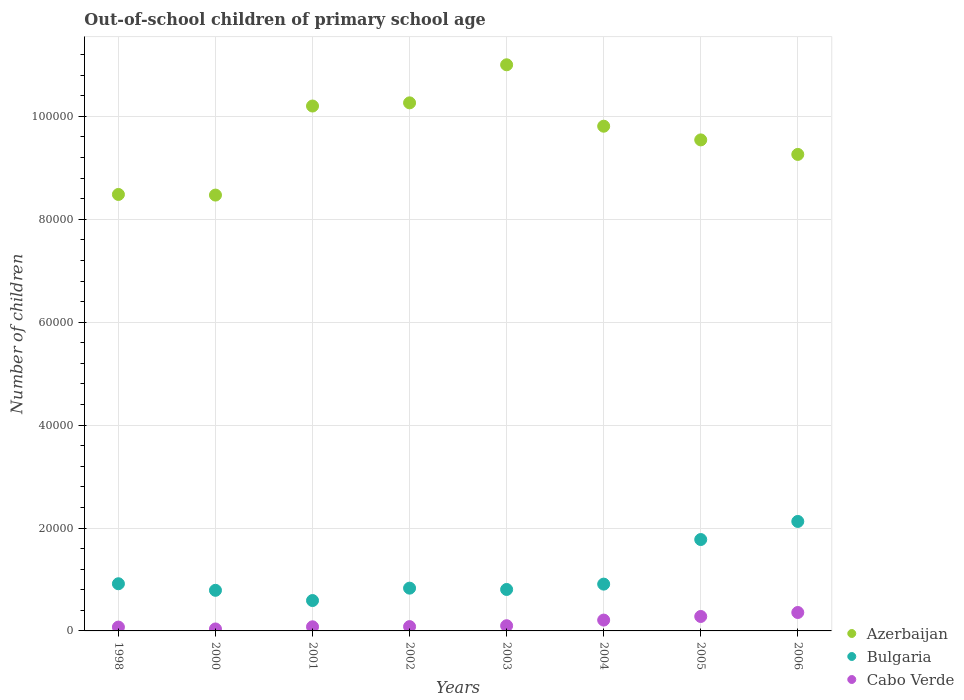What is the number of out-of-school children in Bulgaria in 2000?
Provide a short and direct response. 7892. Across all years, what is the maximum number of out-of-school children in Azerbaijan?
Your answer should be very brief. 1.10e+05. Across all years, what is the minimum number of out-of-school children in Cabo Verde?
Provide a succinct answer. 381. In which year was the number of out-of-school children in Bulgaria maximum?
Make the answer very short. 2006. In which year was the number of out-of-school children in Cabo Verde minimum?
Offer a terse response. 2000. What is the total number of out-of-school children in Azerbaijan in the graph?
Offer a very short reply. 7.70e+05. What is the difference between the number of out-of-school children in Cabo Verde in 2000 and that in 2006?
Offer a terse response. -3200. What is the difference between the number of out-of-school children in Azerbaijan in 2004 and the number of out-of-school children in Cabo Verde in 2005?
Offer a terse response. 9.53e+04. What is the average number of out-of-school children in Bulgaria per year?
Offer a terse response. 1.09e+04. In the year 1998, what is the difference between the number of out-of-school children in Azerbaijan and number of out-of-school children in Cabo Verde?
Keep it short and to the point. 8.41e+04. In how many years, is the number of out-of-school children in Bulgaria greater than 32000?
Make the answer very short. 0. What is the ratio of the number of out-of-school children in Azerbaijan in 2000 to that in 2002?
Give a very brief answer. 0.83. Is the number of out-of-school children in Cabo Verde in 2002 less than that in 2005?
Your answer should be very brief. Yes. Is the difference between the number of out-of-school children in Azerbaijan in 2001 and 2002 greater than the difference between the number of out-of-school children in Cabo Verde in 2001 and 2002?
Offer a very short reply. No. What is the difference between the highest and the second highest number of out-of-school children in Cabo Verde?
Offer a very short reply. 774. What is the difference between the highest and the lowest number of out-of-school children in Azerbaijan?
Your answer should be compact. 2.53e+04. Is the sum of the number of out-of-school children in Cabo Verde in 2003 and 2005 greater than the maximum number of out-of-school children in Bulgaria across all years?
Provide a short and direct response. No. Is the number of out-of-school children in Azerbaijan strictly greater than the number of out-of-school children in Bulgaria over the years?
Your answer should be very brief. Yes. How many dotlines are there?
Keep it short and to the point. 3. How many years are there in the graph?
Your answer should be very brief. 8. Does the graph contain grids?
Provide a succinct answer. Yes. How many legend labels are there?
Your answer should be compact. 3. What is the title of the graph?
Ensure brevity in your answer.  Out-of-school children of primary school age. What is the label or title of the X-axis?
Offer a very short reply. Years. What is the label or title of the Y-axis?
Ensure brevity in your answer.  Number of children. What is the Number of children in Azerbaijan in 1998?
Your response must be concise. 8.48e+04. What is the Number of children of Bulgaria in 1998?
Make the answer very short. 9167. What is the Number of children of Cabo Verde in 1998?
Offer a terse response. 745. What is the Number of children of Azerbaijan in 2000?
Offer a very short reply. 8.47e+04. What is the Number of children in Bulgaria in 2000?
Offer a very short reply. 7892. What is the Number of children of Cabo Verde in 2000?
Provide a short and direct response. 381. What is the Number of children of Azerbaijan in 2001?
Your answer should be compact. 1.02e+05. What is the Number of children in Bulgaria in 2001?
Your answer should be very brief. 5904. What is the Number of children in Cabo Verde in 2001?
Make the answer very short. 801. What is the Number of children of Azerbaijan in 2002?
Make the answer very short. 1.03e+05. What is the Number of children in Bulgaria in 2002?
Your answer should be very brief. 8312. What is the Number of children of Cabo Verde in 2002?
Provide a succinct answer. 836. What is the Number of children of Azerbaijan in 2003?
Give a very brief answer. 1.10e+05. What is the Number of children of Bulgaria in 2003?
Provide a short and direct response. 8057. What is the Number of children in Cabo Verde in 2003?
Offer a terse response. 1011. What is the Number of children in Azerbaijan in 2004?
Make the answer very short. 9.81e+04. What is the Number of children of Bulgaria in 2004?
Your response must be concise. 9096. What is the Number of children of Cabo Verde in 2004?
Your answer should be very brief. 2106. What is the Number of children in Azerbaijan in 2005?
Ensure brevity in your answer.  9.54e+04. What is the Number of children in Bulgaria in 2005?
Give a very brief answer. 1.78e+04. What is the Number of children in Cabo Verde in 2005?
Your answer should be compact. 2807. What is the Number of children in Azerbaijan in 2006?
Make the answer very short. 9.26e+04. What is the Number of children of Bulgaria in 2006?
Offer a very short reply. 2.13e+04. What is the Number of children in Cabo Verde in 2006?
Provide a short and direct response. 3581. Across all years, what is the maximum Number of children in Azerbaijan?
Offer a terse response. 1.10e+05. Across all years, what is the maximum Number of children of Bulgaria?
Your answer should be compact. 2.13e+04. Across all years, what is the maximum Number of children of Cabo Verde?
Provide a succinct answer. 3581. Across all years, what is the minimum Number of children of Azerbaijan?
Provide a short and direct response. 8.47e+04. Across all years, what is the minimum Number of children of Bulgaria?
Provide a succinct answer. 5904. Across all years, what is the minimum Number of children of Cabo Verde?
Your response must be concise. 381. What is the total Number of children of Azerbaijan in the graph?
Offer a very short reply. 7.70e+05. What is the total Number of children of Bulgaria in the graph?
Provide a succinct answer. 8.75e+04. What is the total Number of children in Cabo Verde in the graph?
Your response must be concise. 1.23e+04. What is the difference between the Number of children of Azerbaijan in 1998 and that in 2000?
Ensure brevity in your answer.  121. What is the difference between the Number of children of Bulgaria in 1998 and that in 2000?
Offer a terse response. 1275. What is the difference between the Number of children of Cabo Verde in 1998 and that in 2000?
Keep it short and to the point. 364. What is the difference between the Number of children of Azerbaijan in 1998 and that in 2001?
Provide a succinct answer. -1.72e+04. What is the difference between the Number of children of Bulgaria in 1998 and that in 2001?
Offer a very short reply. 3263. What is the difference between the Number of children in Cabo Verde in 1998 and that in 2001?
Ensure brevity in your answer.  -56. What is the difference between the Number of children of Azerbaijan in 1998 and that in 2002?
Offer a very short reply. -1.78e+04. What is the difference between the Number of children in Bulgaria in 1998 and that in 2002?
Give a very brief answer. 855. What is the difference between the Number of children in Cabo Verde in 1998 and that in 2002?
Ensure brevity in your answer.  -91. What is the difference between the Number of children in Azerbaijan in 1998 and that in 2003?
Provide a short and direct response. -2.52e+04. What is the difference between the Number of children in Bulgaria in 1998 and that in 2003?
Provide a succinct answer. 1110. What is the difference between the Number of children in Cabo Verde in 1998 and that in 2003?
Provide a short and direct response. -266. What is the difference between the Number of children in Azerbaijan in 1998 and that in 2004?
Provide a succinct answer. -1.33e+04. What is the difference between the Number of children in Cabo Verde in 1998 and that in 2004?
Provide a succinct answer. -1361. What is the difference between the Number of children of Azerbaijan in 1998 and that in 2005?
Your answer should be very brief. -1.06e+04. What is the difference between the Number of children in Bulgaria in 1998 and that in 2005?
Your answer should be very brief. -8594. What is the difference between the Number of children in Cabo Verde in 1998 and that in 2005?
Make the answer very short. -2062. What is the difference between the Number of children of Azerbaijan in 1998 and that in 2006?
Offer a terse response. -7781. What is the difference between the Number of children in Bulgaria in 1998 and that in 2006?
Give a very brief answer. -1.21e+04. What is the difference between the Number of children in Cabo Verde in 1998 and that in 2006?
Provide a short and direct response. -2836. What is the difference between the Number of children of Azerbaijan in 2000 and that in 2001?
Your response must be concise. -1.73e+04. What is the difference between the Number of children of Bulgaria in 2000 and that in 2001?
Offer a very short reply. 1988. What is the difference between the Number of children of Cabo Verde in 2000 and that in 2001?
Provide a succinct answer. -420. What is the difference between the Number of children in Azerbaijan in 2000 and that in 2002?
Your answer should be compact. -1.79e+04. What is the difference between the Number of children of Bulgaria in 2000 and that in 2002?
Offer a very short reply. -420. What is the difference between the Number of children in Cabo Verde in 2000 and that in 2002?
Provide a succinct answer. -455. What is the difference between the Number of children in Azerbaijan in 2000 and that in 2003?
Provide a succinct answer. -2.53e+04. What is the difference between the Number of children in Bulgaria in 2000 and that in 2003?
Offer a very short reply. -165. What is the difference between the Number of children of Cabo Verde in 2000 and that in 2003?
Offer a terse response. -630. What is the difference between the Number of children of Azerbaijan in 2000 and that in 2004?
Your answer should be compact. -1.34e+04. What is the difference between the Number of children of Bulgaria in 2000 and that in 2004?
Keep it short and to the point. -1204. What is the difference between the Number of children in Cabo Verde in 2000 and that in 2004?
Give a very brief answer. -1725. What is the difference between the Number of children of Azerbaijan in 2000 and that in 2005?
Your answer should be compact. -1.07e+04. What is the difference between the Number of children in Bulgaria in 2000 and that in 2005?
Offer a very short reply. -9869. What is the difference between the Number of children of Cabo Verde in 2000 and that in 2005?
Keep it short and to the point. -2426. What is the difference between the Number of children in Azerbaijan in 2000 and that in 2006?
Your response must be concise. -7902. What is the difference between the Number of children of Bulgaria in 2000 and that in 2006?
Offer a very short reply. -1.34e+04. What is the difference between the Number of children of Cabo Verde in 2000 and that in 2006?
Provide a succinct answer. -3200. What is the difference between the Number of children of Azerbaijan in 2001 and that in 2002?
Keep it short and to the point. -618. What is the difference between the Number of children in Bulgaria in 2001 and that in 2002?
Provide a succinct answer. -2408. What is the difference between the Number of children of Cabo Verde in 2001 and that in 2002?
Make the answer very short. -35. What is the difference between the Number of children of Azerbaijan in 2001 and that in 2003?
Your response must be concise. -8015. What is the difference between the Number of children in Bulgaria in 2001 and that in 2003?
Make the answer very short. -2153. What is the difference between the Number of children in Cabo Verde in 2001 and that in 2003?
Keep it short and to the point. -210. What is the difference between the Number of children in Azerbaijan in 2001 and that in 2004?
Offer a terse response. 3923. What is the difference between the Number of children in Bulgaria in 2001 and that in 2004?
Offer a very short reply. -3192. What is the difference between the Number of children of Cabo Verde in 2001 and that in 2004?
Make the answer very short. -1305. What is the difference between the Number of children in Azerbaijan in 2001 and that in 2005?
Give a very brief answer. 6583. What is the difference between the Number of children in Bulgaria in 2001 and that in 2005?
Give a very brief answer. -1.19e+04. What is the difference between the Number of children in Cabo Verde in 2001 and that in 2005?
Keep it short and to the point. -2006. What is the difference between the Number of children in Azerbaijan in 2001 and that in 2006?
Your answer should be compact. 9405. What is the difference between the Number of children of Bulgaria in 2001 and that in 2006?
Offer a terse response. -1.54e+04. What is the difference between the Number of children in Cabo Verde in 2001 and that in 2006?
Your response must be concise. -2780. What is the difference between the Number of children in Azerbaijan in 2002 and that in 2003?
Make the answer very short. -7397. What is the difference between the Number of children of Bulgaria in 2002 and that in 2003?
Your response must be concise. 255. What is the difference between the Number of children in Cabo Verde in 2002 and that in 2003?
Ensure brevity in your answer.  -175. What is the difference between the Number of children in Azerbaijan in 2002 and that in 2004?
Give a very brief answer. 4541. What is the difference between the Number of children in Bulgaria in 2002 and that in 2004?
Your response must be concise. -784. What is the difference between the Number of children of Cabo Verde in 2002 and that in 2004?
Your answer should be compact. -1270. What is the difference between the Number of children in Azerbaijan in 2002 and that in 2005?
Make the answer very short. 7201. What is the difference between the Number of children in Bulgaria in 2002 and that in 2005?
Give a very brief answer. -9449. What is the difference between the Number of children in Cabo Verde in 2002 and that in 2005?
Make the answer very short. -1971. What is the difference between the Number of children of Azerbaijan in 2002 and that in 2006?
Offer a very short reply. 1.00e+04. What is the difference between the Number of children of Bulgaria in 2002 and that in 2006?
Keep it short and to the point. -1.30e+04. What is the difference between the Number of children in Cabo Verde in 2002 and that in 2006?
Make the answer very short. -2745. What is the difference between the Number of children of Azerbaijan in 2003 and that in 2004?
Offer a very short reply. 1.19e+04. What is the difference between the Number of children of Bulgaria in 2003 and that in 2004?
Make the answer very short. -1039. What is the difference between the Number of children in Cabo Verde in 2003 and that in 2004?
Make the answer very short. -1095. What is the difference between the Number of children of Azerbaijan in 2003 and that in 2005?
Provide a succinct answer. 1.46e+04. What is the difference between the Number of children of Bulgaria in 2003 and that in 2005?
Provide a succinct answer. -9704. What is the difference between the Number of children of Cabo Verde in 2003 and that in 2005?
Provide a succinct answer. -1796. What is the difference between the Number of children in Azerbaijan in 2003 and that in 2006?
Offer a terse response. 1.74e+04. What is the difference between the Number of children in Bulgaria in 2003 and that in 2006?
Ensure brevity in your answer.  -1.32e+04. What is the difference between the Number of children in Cabo Verde in 2003 and that in 2006?
Provide a short and direct response. -2570. What is the difference between the Number of children in Azerbaijan in 2004 and that in 2005?
Offer a terse response. 2660. What is the difference between the Number of children of Bulgaria in 2004 and that in 2005?
Your answer should be compact. -8665. What is the difference between the Number of children in Cabo Verde in 2004 and that in 2005?
Your answer should be compact. -701. What is the difference between the Number of children of Azerbaijan in 2004 and that in 2006?
Give a very brief answer. 5482. What is the difference between the Number of children of Bulgaria in 2004 and that in 2006?
Provide a succinct answer. -1.22e+04. What is the difference between the Number of children of Cabo Verde in 2004 and that in 2006?
Provide a succinct answer. -1475. What is the difference between the Number of children of Azerbaijan in 2005 and that in 2006?
Provide a succinct answer. 2822. What is the difference between the Number of children of Bulgaria in 2005 and that in 2006?
Make the answer very short. -3516. What is the difference between the Number of children in Cabo Verde in 2005 and that in 2006?
Provide a succinct answer. -774. What is the difference between the Number of children of Azerbaijan in 1998 and the Number of children of Bulgaria in 2000?
Your answer should be compact. 7.69e+04. What is the difference between the Number of children of Azerbaijan in 1998 and the Number of children of Cabo Verde in 2000?
Offer a terse response. 8.44e+04. What is the difference between the Number of children in Bulgaria in 1998 and the Number of children in Cabo Verde in 2000?
Keep it short and to the point. 8786. What is the difference between the Number of children in Azerbaijan in 1998 and the Number of children in Bulgaria in 2001?
Your response must be concise. 7.89e+04. What is the difference between the Number of children of Azerbaijan in 1998 and the Number of children of Cabo Verde in 2001?
Provide a short and direct response. 8.40e+04. What is the difference between the Number of children of Bulgaria in 1998 and the Number of children of Cabo Verde in 2001?
Your answer should be very brief. 8366. What is the difference between the Number of children of Azerbaijan in 1998 and the Number of children of Bulgaria in 2002?
Provide a succinct answer. 7.65e+04. What is the difference between the Number of children in Azerbaijan in 1998 and the Number of children in Cabo Verde in 2002?
Give a very brief answer. 8.40e+04. What is the difference between the Number of children in Bulgaria in 1998 and the Number of children in Cabo Verde in 2002?
Provide a succinct answer. 8331. What is the difference between the Number of children of Azerbaijan in 1998 and the Number of children of Bulgaria in 2003?
Your answer should be compact. 7.68e+04. What is the difference between the Number of children of Azerbaijan in 1998 and the Number of children of Cabo Verde in 2003?
Ensure brevity in your answer.  8.38e+04. What is the difference between the Number of children in Bulgaria in 1998 and the Number of children in Cabo Verde in 2003?
Offer a terse response. 8156. What is the difference between the Number of children of Azerbaijan in 1998 and the Number of children of Bulgaria in 2004?
Your answer should be compact. 7.57e+04. What is the difference between the Number of children in Azerbaijan in 1998 and the Number of children in Cabo Verde in 2004?
Give a very brief answer. 8.27e+04. What is the difference between the Number of children of Bulgaria in 1998 and the Number of children of Cabo Verde in 2004?
Offer a very short reply. 7061. What is the difference between the Number of children in Azerbaijan in 1998 and the Number of children in Bulgaria in 2005?
Provide a short and direct response. 6.71e+04. What is the difference between the Number of children of Azerbaijan in 1998 and the Number of children of Cabo Verde in 2005?
Your answer should be compact. 8.20e+04. What is the difference between the Number of children in Bulgaria in 1998 and the Number of children in Cabo Verde in 2005?
Provide a succinct answer. 6360. What is the difference between the Number of children in Azerbaijan in 1998 and the Number of children in Bulgaria in 2006?
Provide a short and direct response. 6.35e+04. What is the difference between the Number of children of Azerbaijan in 1998 and the Number of children of Cabo Verde in 2006?
Give a very brief answer. 8.12e+04. What is the difference between the Number of children of Bulgaria in 1998 and the Number of children of Cabo Verde in 2006?
Keep it short and to the point. 5586. What is the difference between the Number of children in Azerbaijan in 2000 and the Number of children in Bulgaria in 2001?
Make the answer very short. 7.88e+04. What is the difference between the Number of children of Azerbaijan in 2000 and the Number of children of Cabo Verde in 2001?
Your answer should be compact. 8.39e+04. What is the difference between the Number of children of Bulgaria in 2000 and the Number of children of Cabo Verde in 2001?
Give a very brief answer. 7091. What is the difference between the Number of children of Azerbaijan in 2000 and the Number of children of Bulgaria in 2002?
Provide a short and direct response. 7.64e+04. What is the difference between the Number of children of Azerbaijan in 2000 and the Number of children of Cabo Verde in 2002?
Give a very brief answer. 8.39e+04. What is the difference between the Number of children of Bulgaria in 2000 and the Number of children of Cabo Verde in 2002?
Keep it short and to the point. 7056. What is the difference between the Number of children in Azerbaijan in 2000 and the Number of children in Bulgaria in 2003?
Keep it short and to the point. 7.66e+04. What is the difference between the Number of children of Azerbaijan in 2000 and the Number of children of Cabo Verde in 2003?
Give a very brief answer. 8.37e+04. What is the difference between the Number of children in Bulgaria in 2000 and the Number of children in Cabo Verde in 2003?
Your answer should be very brief. 6881. What is the difference between the Number of children of Azerbaijan in 2000 and the Number of children of Bulgaria in 2004?
Your answer should be very brief. 7.56e+04. What is the difference between the Number of children of Azerbaijan in 2000 and the Number of children of Cabo Verde in 2004?
Give a very brief answer. 8.26e+04. What is the difference between the Number of children in Bulgaria in 2000 and the Number of children in Cabo Verde in 2004?
Your answer should be compact. 5786. What is the difference between the Number of children of Azerbaijan in 2000 and the Number of children of Bulgaria in 2005?
Provide a short and direct response. 6.69e+04. What is the difference between the Number of children of Azerbaijan in 2000 and the Number of children of Cabo Verde in 2005?
Keep it short and to the point. 8.19e+04. What is the difference between the Number of children of Bulgaria in 2000 and the Number of children of Cabo Verde in 2005?
Provide a succinct answer. 5085. What is the difference between the Number of children in Azerbaijan in 2000 and the Number of children in Bulgaria in 2006?
Keep it short and to the point. 6.34e+04. What is the difference between the Number of children of Azerbaijan in 2000 and the Number of children of Cabo Verde in 2006?
Give a very brief answer. 8.11e+04. What is the difference between the Number of children of Bulgaria in 2000 and the Number of children of Cabo Verde in 2006?
Offer a terse response. 4311. What is the difference between the Number of children in Azerbaijan in 2001 and the Number of children in Bulgaria in 2002?
Your answer should be very brief. 9.37e+04. What is the difference between the Number of children of Azerbaijan in 2001 and the Number of children of Cabo Verde in 2002?
Keep it short and to the point. 1.01e+05. What is the difference between the Number of children in Bulgaria in 2001 and the Number of children in Cabo Verde in 2002?
Ensure brevity in your answer.  5068. What is the difference between the Number of children of Azerbaijan in 2001 and the Number of children of Bulgaria in 2003?
Your response must be concise. 9.40e+04. What is the difference between the Number of children of Azerbaijan in 2001 and the Number of children of Cabo Verde in 2003?
Your answer should be compact. 1.01e+05. What is the difference between the Number of children in Bulgaria in 2001 and the Number of children in Cabo Verde in 2003?
Keep it short and to the point. 4893. What is the difference between the Number of children of Azerbaijan in 2001 and the Number of children of Bulgaria in 2004?
Provide a short and direct response. 9.29e+04. What is the difference between the Number of children in Azerbaijan in 2001 and the Number of children in Cabo Verde in 2004?
Your answer should be compact. 9.99e+04. What is the difference between the Number of children of Bulgaria in 2001 and the Number of children of Cabo Verde in 2004?
Your answer should be compact. 3798. What is the difference between the Number of children in Azerbaijan in 2001 and the Number of children in Bulgaria in 2005?
Your answer should be compact. 8.42e+04. What is the difference between the Number of children in Azerbaijan in 2001 and the Number of children in Cabo Verde in 2005?
Ensure brevity in your answer.  9.92e+04. What is the difference between the Number of children in Bulgaria in 2001 and the Number of children in Cabo Verde in 2005?
Ensure brevity in your answer.  3097. What is the difference between the Number of children of Azerbaijan in 2001 and the Number of children of Bulgaria in 2006?
Your answer should be compact. 8.07e+04. What is the difference between the Number of children of Azerbaijan in 2001 and the Number of children of Cabo Verde in 2006?
Provide a short and direct response. 9.84e+04. What is the difference between the Number of children of Bulgaria in 2001 and the Number of children of Cabo Verde in 2006?
Offer a very short reply. 2323. What is the difference between the Number of children of Azerbaijan in 2002 and the Number of children of Bulgaria in 2003?
Provide a short and direct response. 9.46e+04. What is the difference between the Number of children of Azerbaijan in 2002 and the Number of children of Cabo Verde in 2003?
Keep it short and to the point. 1.02e+05. What is the difference between the Number of children of Bulgaria in 2002 and the Number of children of Cabo Verde in 2003?
Your answer should be compact. 7301. What is the difference between the Number of children in Azerbaijan in 2002 and the Number of children in Bulgaria in 2004?
Give a very brief answer. 9.35e+04. What is the difference between the Number of children in Azerbaijan in 2002 and the Number of children in Cabo Verde in 2004?
Give a very brief answer. 1.01e+05. What is the difference between the Number of children in Bulgaria in 2002 and the Number of children in Cabo Verde in 2004?
Offer a very short reply. 6206. What is the difference between the Number of children in Azerbaijan in 2002 and the Number of children in Bulgaria in 2005?
Your response must be concise. 8.49e+04. What is the difference between the Number of children of Azerbaijan in 2002 and the Number of children of Cabo Verde in 2005?
Offer a terse response. 9.98e+04. What is the difference between the Number of children in Bulgaria in 2002 and the Number of children in Cabo Verde in 2005?
Give a very brief answer. 5505. What is the difference between the Number of children in Azerbaijan in 2002 and the Number of children in Bulgaria in 2006?
Your answer should be very brief. 8.14e+04. What is the difference between the Number of children of Azerbaijan in 2002 and the Number of children of Cabo Verde in 2006?
Keep it short and to the point. 9.90e+04. What is the difference between the Number of children of Bulgaria in 2002 and the Number of children of Cabo Verde in 2006?
Keep it short and to the point. 4731. What is the difference between the Number of children of Azerbaijan in 2003 and the Number of children of Bulgaria in 2004?
Provide a succinct answer. 1.01e+05. What is the difference between the Number of children in Azerbaijan in 2003 and the Number of children in Cabo Verde in 2004?
Your answer should be very brief. 1.08e+05. What is the difference between the Number of children in Bulgaria in 2003 and the Number of children in Cabo Verde in 2004?
Keep it short and to the point. 5951. What is the difference between the Number of children in Azerbaijan in 2003 and the Number of children in Bulgaria in 2005?
Offer a very short reply. 9.23e+04. What is the difference between the Number of children of Azerbaijan in 2003 and the Number of children of Cabo Verde in 2005?
Give a very brief answer. 1.07e+05. What is the difference between the Number of children in Bulgaria in 2003 and the Number of children in Cabo Verde in 2005?
Provide a succinct answer. 5250. What is the difference between the Number of children in Azerbaijan in 2003 and the Number of children in Bulgaria in 2006?
Offer a terse response. 8.87e+04. What is the difference between the Number of children of Azerbaijan in 2003 and the Number of children of Cabo Verde in 2006?
Offer a terse response. 1.06e+05. What is the difference between the Number of children in Bulgaria in 2003 and the Number of children in Cabo Verde in 2006?
Offer a very short reply. 4476. What is the difference between the Number of children of Azerbaijan in 2004 and the Number of children of Bulgaria in 2005?
Ensure brevity in your answer.  8.03e+04. What is the difference between the Number of children in Azerbaijan in 2004 and the Number of children in Cabo Verde in 2005?
Ensure brevity in your answer.  9.53e+04. What is the difference between the Number of children in Bulgaria in 2004 and the Number of children in Cabo Verde in 2005?
Keep it short and to the point. 6289. What is the difference between the Number of children in Azerbaijan in 2004 and the Number of children in Bulgaria in 2006?
Your answer should be compact. 7.68e+04. What is the difference between the Number of children of Azerbaijan in 2004 and the Number of children of Cabo Verde in 2006?
Your answer should be compact. 9.45e+04. What is the difference between the Number of children in Bulgaria in 2004 and the Number of children in Cabo Verde in 2006?
Keep it short and to the point. 5515. What is the difference between the Number of children of Azerbaijan in 2005 and the Number of children of Bulgaria in 2006?
Give a very brief answer. 7.42e+04. What is the difference between the Number of children in Azerbaijan in 2005 and the Number of children in Cabo Verde in 2006?
Keep it short and to the point. 9.18e+04. What is the difference between the Number of children in Bulgaria in 2005 and the Number of children in Cabo Verde in 2006?
Offer a terse response. 1.42e+04. What is the average Number of children of Azerbaijan per year?
Ensure brevity in your answer.  9.63e+04. What is the average Number of children in Bulgaria per year?
Provide a short and direct response. 1.09e+04. What is the average Number of children in Cabo Verde per year?
Your answer should be compact. 1533.5. In the year 1998, what is the difference between the Number of children in Azerbaijan and Number of children in Bulgaria?
Give a very brief answer. 7.57e+04. In the year 1998, what is the difference between the Number of children of Azerbaijan and Number of children of Cabo Verde?
Keep it short and to the point. 8.41e+04. In the year 1998, what is the difference between the Number of children of Bulgaria and Number of children of Cabo Verde?
Provide a short and direct response. 8422. In the year 2000, what is the difference between the Number of children of Azerbaijan and Number of children of Bulgaria?
Your answer should be compact. 7.68e+04. In the year 2000, what is the difference between the Number of children of Azerbaijan and Number of children of Cabo Verde?
Offer a terse response. 8.43e+04. In the year 2000, what is the difference between the Number of children of Bulgaria and Number of children of Cabo Verde?
Make the answer very short. 7511. In the year 2001, what is the difference between the Number of children of Azerbaijan and Number of children of Bulgaria?
Your response must be concise. 9.61e+04. In the year 2001, what is the difference between the Number of children of Azerbaijan and Number of children of Cabo Verde?
Offer a terse response. 1.01e+05. In the year 2001, what is the difference between the Number of children in Bulgaria and Number of children in Cabo Verde?
Give a very brief answer. 5103. In the year 2002, what is the difference between the Number of children of Azerbaijan and Number of children of Bulgaria?
Your answer should be compact. 9.43e+04. In the year 2002, what is the difference between the Number of children in Azerbaijan and Number of children in Cabo Verde?
Your answer should be compact. 1.02e+05. In the year 2002, what is the difference between the Number of children in Bulgaria and Number of children in Cabo Verde?
Your answer should be compact. 7476. In the year 2003, what is the difference between the Number of children of Azerbaijan and Number of children of Bulgaria?
Give a very brief answer. 1.02e+05. In the year 2003, what is the difference between the Number of children of Azerbaijan and Number of children of Cabo Verde?
Ensure brevity in your answer.  1.09e+05. In the year 2003, what is the difference between the Number of children in Bulgaria and Number of children in Cabo Verde?
Your answer should be very brief. 7046. In the year 2004, what is the difference between the Number of children of Azerbaijan and Number of children of Bulgaria?
Offer a very short reply. 8.90e+04. In the year 2004, what is the difference between the Number of children of Azerbaijan and Number of children of Cabo Verde?
Your response must be concise. 9.60e+04. In the year 2004, what is the difference between the Number of children of Bulgaria and Number of children of Cabo Verde?
Provide a succinct answer. 6990. In the year 2005, what is the difference between the Number of children of Azerbaijan and Number of children of Bulgaria?
Your response must be concise. 7.77e+04. In the year 2005, what is the difference between the Number of children of Azerbaijan and Number of children of Cabo Verde?
Provide a succinct answer. 9.26e+04. In the year 2005, what is the difference between the Number of children of Bulgaria and Number of children of Cabo Verde?
Make the answer very short. 1.50e+04. In the year 2006, what is the difference between the Number of children of Azerbaijan and Number of children of Bulgaria?
Offer a terse response. 7.13e+04. In the year 2006, what is the difference between the Number of children of Azerbaijan and Number of children of Cabo Verde?
Provide a short and direct response. 8.90e+04. In the year 2006, what is the difference between the Number of children of Bulgaria and Number of children of Cabo Verde?
Your answer should be very brief. 1.77e+04. What is the ratio of the Number of children in Bulgaria in 1998 to that in 2000?
Offer a terse response. 1.16. What is the ratio of the Number of children of Cabo Verde in 1998 to that in 2000?
Give a very brief answer. 1.96. What is the ratio of the Number of children in Azerbaijan in 1998 to that in 2001?
Your answer should be very brief. 0.83. What is the ratio of the Number of children of Bulgaria in 1998 to that in 2001?
Keep it short and to the point. 1.55. What is the ratio of the Number of children in Cabo Verde in 1998 to that in 2001?
Your response must be concise. 0.93. What is the ratio of the Number of children of Azerbaijan in 1998 to that in 2002?
Provide a short and direct response. 0.83. What is the ratio of the Number of children in Bulgaria in 1998 to that in 2002?
Your answer should be very brief. 1.1. What is the ratio of the Number of children of Cabo Verde in 1998 to that in 2002?
Your answer should be compact. 0.89. What is the ratio of the Number of children of Azerbaijan in 1998 to that in 2003?
Offer a terse response. 0.77. What is the ratio of the Number of children of Bulgaria in 1998 to that in 2003?
Give a very brief answer. 1.14. What is the ratio of the Number of children of Cabo Verde in 1998 to that in 2003?
Make the answer very short. 0.74. What is the ratio of the Number of children in Azerbaijan in 1998 to that in 2004?
Your answer should be very brief. 0.86. What is the ratio of the Number of children in Bulgaria in 1998 to that in 2004?
Your answer should be very brief. 1.01. What is the ratio of the Number of children in Cabo Verde in 1998 to that in 2004?
Your answer should be very brief. 0.35. What is the ratio of the Number of children of Azerbaijan in 1998 to that in 2005?
Offer a very short reply. 0.89. What is the ratio of the Number of children in Bulgaria in 1998 to that in 2005?
Your answer should be very brief. 0.52. What is the ratio of the Number of children of Cabo Verde in 1998 to that in 2005?
Provide a short and direct response. 0.27. What is the ratio of the Number of children in Azerbaijan in 1998 to that in 2006?
Provide a short and direct response. 0.92. What is the ratio of the Number of children in Bulgaria in 1998 to that in 2006?
Offer a terse response. 0.43. What is the ratio of the Number of children in Cabo Verde in 1998 to that in 2006?
Ensure brevity in your answer.  0.21. What is the ratio of the Number of children of Azerbaijan in 2000 to that in 2001?
Provide a succinct answer. 0.83. What is the ratio of the Number of children of Bulgaria in 2000 to that in 2001?
Keep it short and to the point. 1.34. What is the ratio of the Number of children of Cabo Verde in 2000 to that in 2001?
Ensure brevity in your answer.  0.48. What is the ratio of the Number of children of Azerbaijan in 2000 to that in 2002?
Ensure brevity in your answer.  0.83. What is the ratio of the Number of children in Bulgaria in 2000 to that in 2002?
Make the answer very short. 0.95. What is the ratio of the Number of children in Cabo Verde in 2000 to that in 2002?
Give a very brief answer. 0.46. What is the ratio of the Number of children of Azerbaijan in 2000 to that in 2003?
Give a very brief answer. 0.77. What is the ratio of the Number of children of Bulgaria in 2000 to that in 2003?
Your answer should be compact. 0.98. What is the ratio of the Number of children in Cabo Verde in 2000 to that in 2003?
Keep it short and to the point. 0.38. What is the ratio of the Number of children of Azerbaijan in 2000 to that in 2004?
Provide a short and direct response. 0.86. What is the ratio of the Number of children in Bulgaria in 2000 to that in 2004?
Make the answer very short. 0.87. What is the ratio of the Number of children in Cabo Verde in 2000 to that in 2004?
Your answer should be compact. 0.18. What is the ratio of the Number of children in Azerbaijan in 2000 to that in 2005?
Provide a succinct answer. 0.89. What is the ratio of the Number of children in Bulgaria in 2000 to that in 2005?
Provide a short and direct response. 0.44. What is the ratio of the Number of children in Cabo Verde in 2000 to that in 2005?
Keep it short and to the point. 0.14. What is the ratio of the Number of children of Azerbaijan in 2000 to that in 2006?
Your response must be concise. 0.91. What is the ratio of the Number of children in Bulgaria in 2000 to that in 2006?
Offer a terse response. 0.37. What is the ratio of the Number of children in Cabo Verde in 2000 to that in 2006?
Give a very brief answer. 0.11. What is the ratio of the Number of children of Bulgaria in 2001 to that in 2002?
Offer a terse response. 0.71. What is the ratio of the Number of children in Cabo Verde in 2001 to that in 2002?
Provide a succinct answer. 0.96. What is the ratio of the Number of children in Azerbaijan in 2001 to that in 2003?
Keep it short and to the point. 0.93. What is the ratio of the Number of children in Bulgaria in 2001 to that in 2003?
Provide a short and direct response. 0.73. What is the ratio of the Number of children of Cabo Verde in 2001 to that in 2003?
Keep it short and to the point. 0.79. What is the ratio of the Number of children of Bulgaria in 2001 to that in 2004?
Provide a succinct answer. 0.65. What is the ratio of the Number of children in Cabo Verde in 2001 to that in 2004?
Provide a short and direct response. 0.38. What is the ratio of the Number of children in Azerbaijan in 2001 to that in 2005?
Give a very brief answer. 1.07. What is the ratio of the Number of children of Bulgaria in 2001 to that in 2005?
Your response must be concise. 0.33. What is the ratio of the Number of children of Cabo Verde in 2001 to that in 2005?
Make the answer very short. 0.29. What is the ratio of the Number of children of Azerbaijan in 2001 to that in 2006?
Your response must be concise. 1.1. What is the ratio of the Number of children in Bulgaria in 2001 to that in 2006?
Give a very brief answer. 0.28. What is the ratio of the Number of children in Cabo Verde in 2001 to that in 2006?
Offer a very short reply. 0.22. What is the ratio of the Number of children of Azerbaijan in 2002 to that in 2003?
Your answer should be compact. 0.93. What is the ratio of the Number of children of Bulgaria in 2002 to that in 2003?
Ensure brevity in your answer.  1.03. What is the ratio of the Number of children in Cabo Verde in 2002 to that in 2003?
Ensure brevity in your answer.  0.83. What is the ratio of the Number of children in Azerbaijan in 2002 to that in 2004?
Your answer should be compact. 1.05. What is the ratio of the Number of children in Bulgaria in 2002 to that in 2004?
Ensure brevity in your answer.  0.91. What is the ratio of the Number of children of Cabo Verde in 2002 to that in 2004?
Your answer should be very brief. 0.4. What is the ratio of the Number of children in Azerbaijan in 2002 to that in 2005?
Offer a very short reply. 1.08. What is the ratio of the Number of children in Bulgaria in 2002 to that in 2005?
Your answer should be compact. 0.47. What is the ratio of the Number of children in Cabo Verde in 2002 to that in 2005?
Provide a short and direct response. 0.3. What is the ratio of the Number of children in Azerbaijan in 2002 to that in 2006?
Your response must be concise. 1.11. What is the ratio of the Number of children of Bulgaria in 2002 to that in 2006?
Your answer should be compact. 0.39. What is the ratio of the Number of children of Cabo Verde in 2002 to that in 2006?
Your answer should be very brief. 0.23. What is the ratio of the Number of children of Azerbaijan in 2003 to that in 2004?
Offer a very short reply. 1.12. What is the ratio of the Number of children in Bulgaria in 2003 to that in 2004?
Make the answer very short. 0.89. What is the ratio of the Number of children in Cabo Verde in 2003 to that in 2004?
Offer a terse response. 0.48. What is the ratio of the Number of children of Azerbaijan in 2003 to that in 2005?
Keep it short and to the point. 1.15. What is the ratio of the Number of children of Bulgaria in 2003 to that in 2005?
Keep it short and to the point. 0.45. What is the ratio of the Number of children in Cabo Verde in 2003 to that in 2005?
Your answer should be very brief. 0.36. What is the ratio of the Number of children in Azerbaijan in 2003 to that in 2006?
Your answer should be compact. 1.19. What is the ratio of the Number of children in Bulgaria in 2003 to that in 2006?
Provide a succinct answer. 0.38. What is the ratio of the Number of children of Cabo Verde in 2003 to that in 2006?
Provide a succinct answer. 0.28. What is the ratio of the Number of children of Azerbaijan in 2004 to that in 2005?
Your answer should be very brief. 1.03. What is the ratio of the Number of children of Bulgaria in 2004 to that in 2005?
Keep it short and to the point. 0.51. What is the ratio of the Number of children of Cabo Verde in 2004 to that in 2005?
Your answer should be compact. 0.75. What is the ratio of the Number of children of Azerbaijan in 2004 to that in 2006?
Provide a succinct answer. 1.06. What is the ratio of the Number of children in Bulgaria in 2004 to that in 2006?
Keep it short and to the point. 0.43. What is the ratio of the Number of children of Cabo Verde in 2004 to that in 2006?
Keep it short and to the point. 0.59. What is the ratio of the Number of children of Azerbaijan in 2005 to that in 2006?
Your answer should be very brief. 1.03. What is the ratio of the Number of children of Bulgaria in 2005 to that in 2006?
Your response must be concise. 0.83. What is the ratio of the Number of children of Cabo Verde in 2005 to that in 2006?
Your answer should be compact. 0.78. What is the difference between the highest and the second highest Number of children in Azerbaijan?
Your response must be concise. 7397. What is the difference between the highest and the second highest Number of children of Bulgaria?
Offer a very short reply. 3516. What is the difference between the highest and the second highest Number of children in Cabo Verde?
Your response must be concise. 774. What is the difference between the highest and the lowest Number of children in Azerbaijan?
Provide a succinct answer. 2.53e+04. What is the difference between the highest and the lowest Number of children of Bulgaria?
Offer a terse response. 1.54e+04. What is the difference between the highest and the lowest Number of children in Cabo Verde?
Offer a terse response. 3200. 